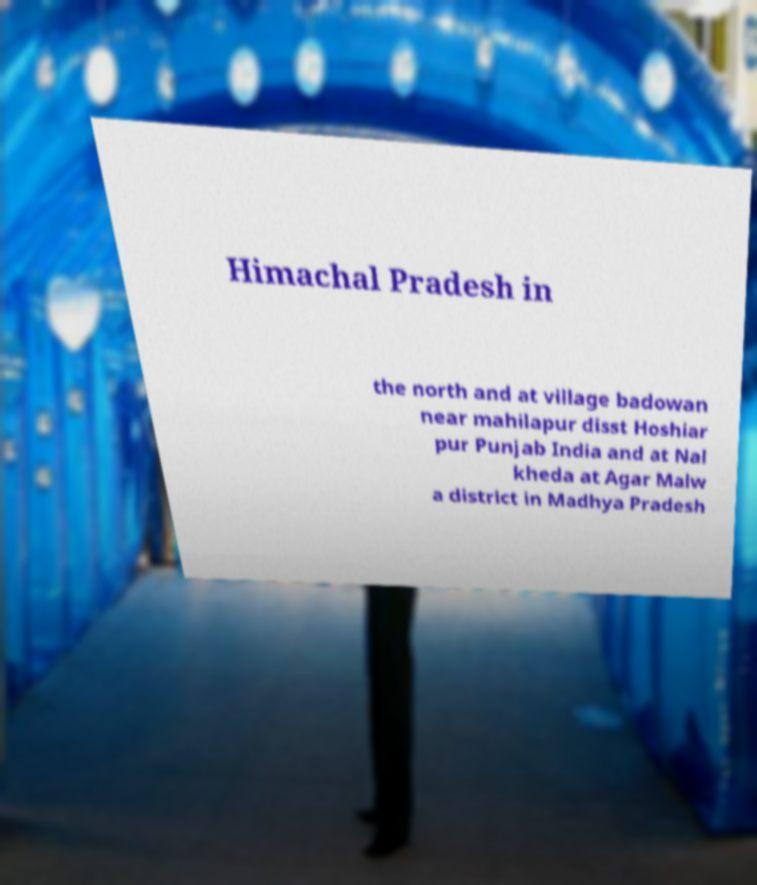Could you assist in decoding the text presented in this image and type it out clearly? Himachal Pradesh in the north and at village badowan near mahilapur disst Hoshiar pur Punjab India and at Nal kheda at Agar Malw a district in Madhya Pradesh 